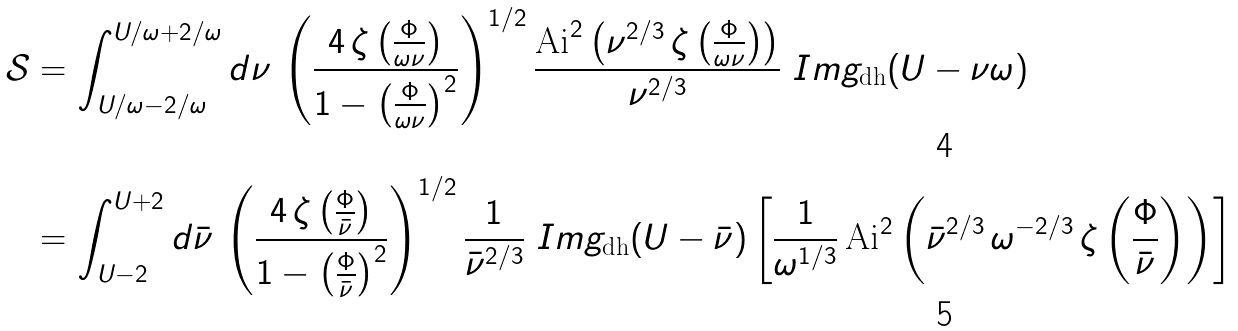Convert formula to latex. <formula><loc_0><loc_0><loc_500><loc_500>\mathcal { S } & = \int _ { U / \omega - 2 / \omega } ^ { U / \omega + 2 / \omega } d \nu \, \left ( \frac { 4 \, \zeta \left ( \frac { \Phi } { \omega \nu } \right ) } { 1 - \left ( \frac { \Phi } { \omega \nu } \right ) ^ { 2 } } \right ) ^ { 1 / 2 } \frac { \text {Ai} ^ { 2 } \left ( \nu ^ { 2 / 3 } \, \zeta \left ( \frac { \Phi } { \omega \nu } \right ) \right ) } { \nu ^ { 2 / 3 } } \ I m g _ { \text {dh} } ( U - \nu \omega ) \\ & = \int _ { U - 2 } ^ { U + 2 } d \bar { \nu } \, \left ( \frac { 4 \, \zeta \left ( \frac { \Phi } { \bar { \nu } } \right ) } { 1 - \left ( \frac { \Phi } { \bar { \nu } } \right ) ^ { 2 } } \right ) ^ { 1 / 2 } \frac { 1 } { \bar { \nu } ^ { 2 / 3 } } \ I m g _ { \text {dh} } ( U - \bar { \nu } ) \left [ \frac { 1 } { \omega ^ { 1 / 3 } } \, \text {Ai} ^ { 2 } \left ( \bar { \nu } ^ { 2 / 3 } \, \omega ^ { - 2 / 3 } \, \zeta \left ( \frac { \Phi } { \bar { \nu } } \right ) \right ) \right ]</formula> 